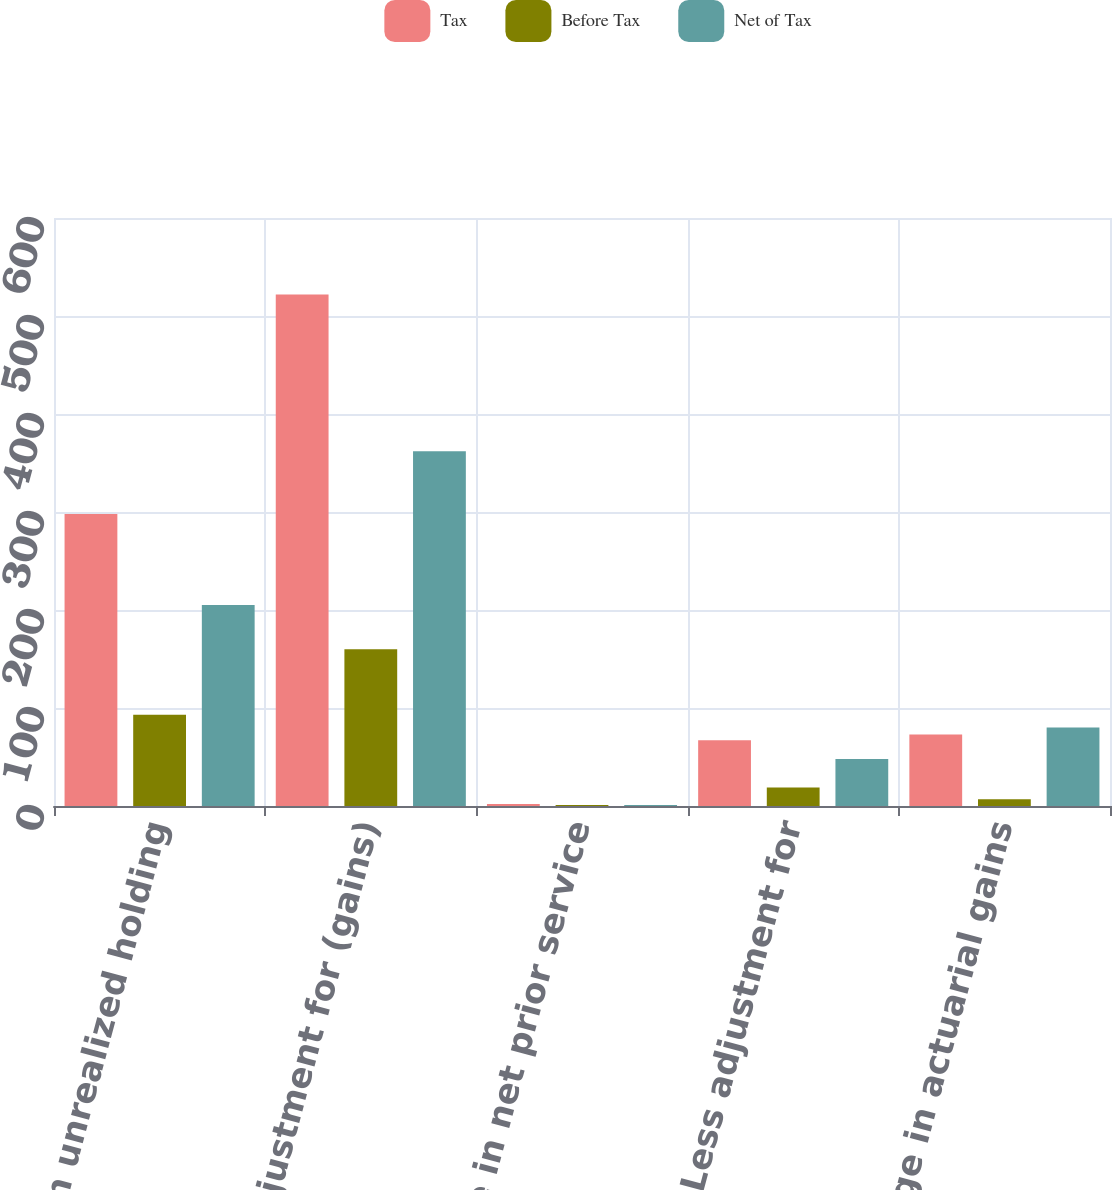<chart> <loc_0><loc_0><loc_500><loc_500><stacked_bar_chart><ecel><fcel>Change in unrealized holding<fcel>Less adjustment for (gains)<fcel>Change in net prior service<fcel>Less adjustment for<fcel>Change in actuarial gains<nl><fcel>Tax<fcel>298<fcel>522<fcel>2<fcel>67<fcel>73<nl><fcel>Before Tax<fcel>93<fcel>160<fcel>1<fcel>19<fcel>7<nl><fcel>Net of Tax<fcel>205<fcel>362<fcel>1<fcel>48<fcel>80<nl></chart> 